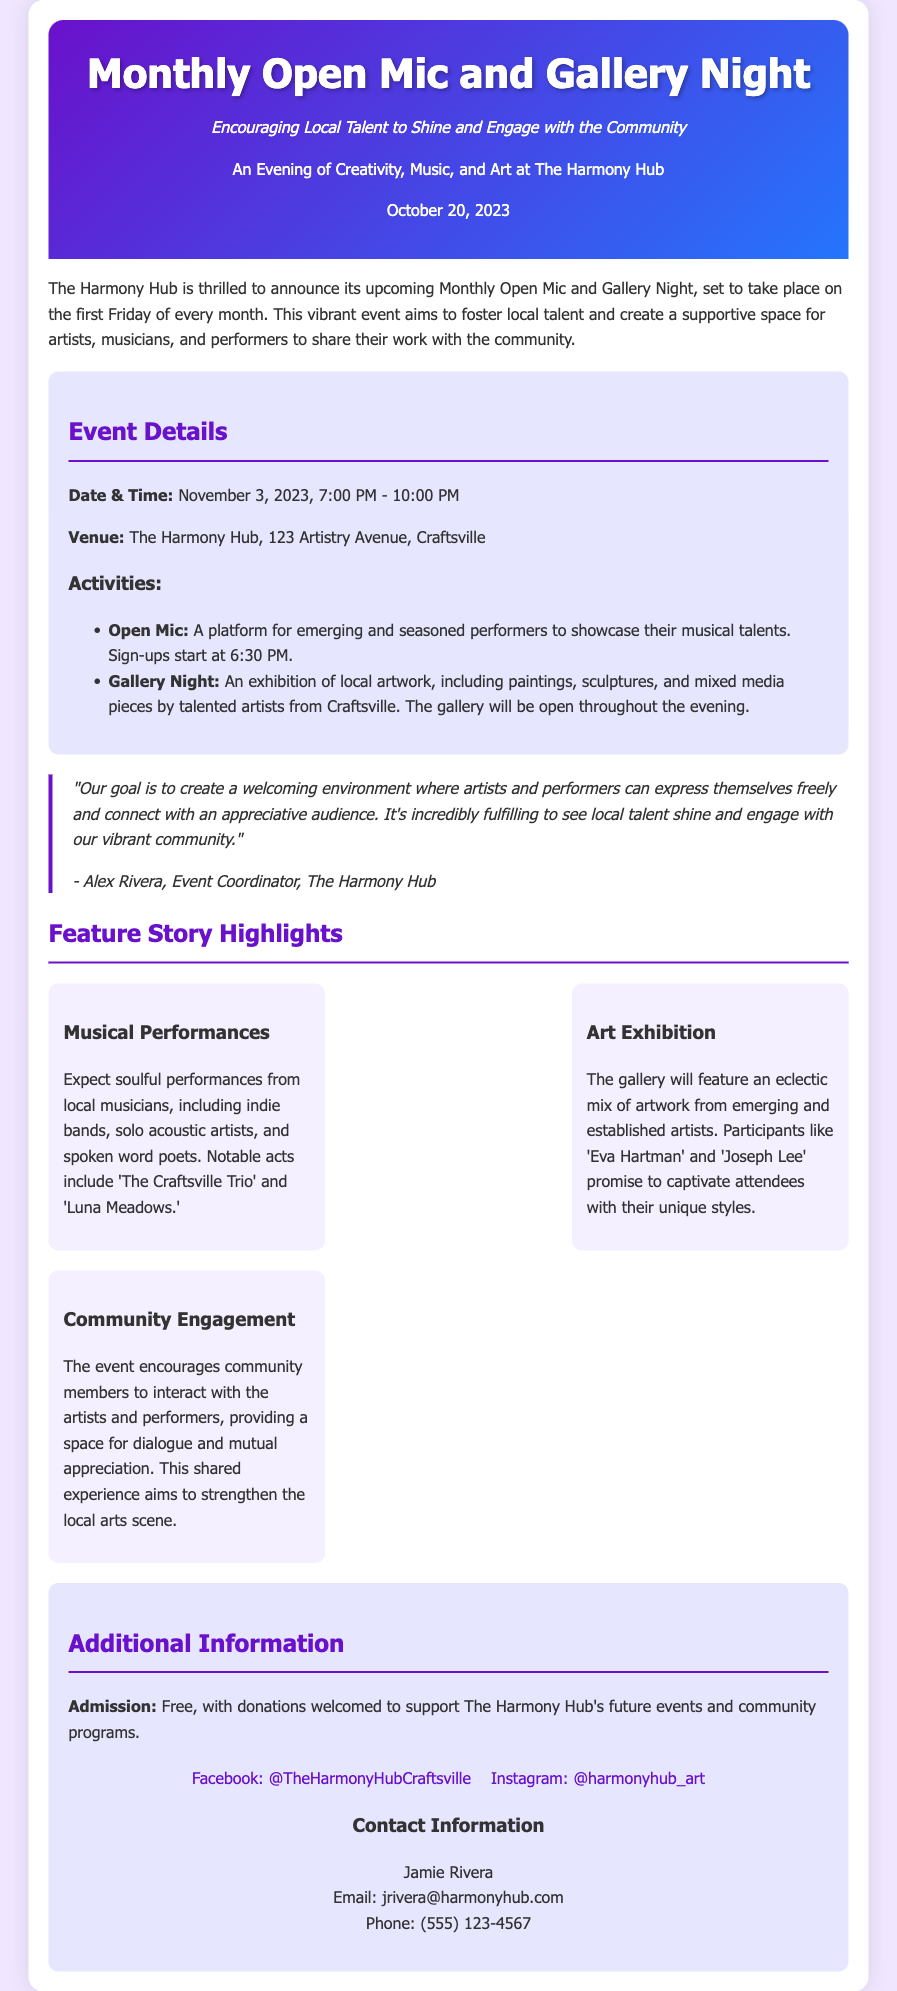what is the date of the event? The date of the Monthly Open Mic and Gallery Night is mentioned in the event details section.
Answer: November 3, 2023 what time does the event start? The starting time of the event can be found in the event details section.
Answer: 7:00 PM where is the event taking place? The venue for the event is specified in the event details section.
Answer: The Harmony Hub, 123 Artistry Avenue, Craftsville who is the event coordinator? The quote section provides the name of the person coordinating the event.
Answer: Alex Rivera is there an admission fee for the event? The admission information is detailed in the additional information section.
Answer: Free what will be featured at the Gallery Night? The activities happening during the Gallery Night are described in the event details.
Answer: Local artwork what is encouraged during the event? The purpose of the event related to community interaction is mentioned in the feature story highlights.
Answer: Community engagement what are the social media platforms listed? The social media section of the document specifies where to find more information online.
Answer: Facebook and Instagram what type of performances can attendees expect? The feature story highlights describe the variety of performances at the event.
Answer: Musical performances 